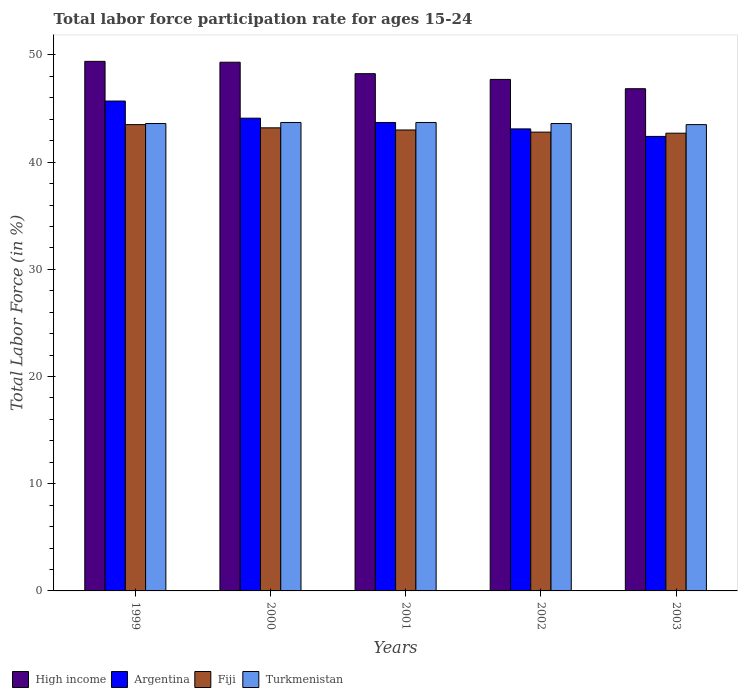Are the number of bars on each tick of the X-axis equal?
Your response must be concise. Yes. How many bars are there on the 4th tick from the left?
Ensure brevity in your answer.  4. What is the labor force participation rate in Argentina in 1999?
Give a very brief answer. 45.7. Across all years, what is the maximum labor force participation rate in Turkmenistan?
Your response must be concise. 43.7. Across all years, what is the minimum labor force participation rate in Fiji?
Provide a succinct answer. 42.7. What is the total labor force participation rate in Turkmenistan in the graph?
Give a very brief answer. 218.1. What is the difference between the labor force participation rate in Argentina in 1999 and that in 2002?
Give a very brief answer. 2.6. What is the difference between the labor force participation rate in Argentina in 2000 and the labor force participation rate in High income in 2002?
Keep it short and to the point. -3.62. What is the average labor force participation rate in Argentina per year?
Provide a short and direct response. 43.8. In the year 2003, what is the difference between the labor force participation rate in Turkmenistan and labor force participation rate in High income?
Make the answer very short. -3.35. What is the ratio of the labor force participation rate in Turkmenistan in 1999 to that in 2003?
Provide a succinct answer. 1. Is the labor force participation rate in Argentina in 2001 less than that in 2003?
Provide a succinct answer. No. What is the difference between the highest and the second highest labor force participation rate in Fiji?
Ensure brevity in your answer.  0.3. What is the difference between the highest and the lowest labor force participation rate in Turkmenistan?
Provide a succinct answer. 0.2. Is the sum of the labor force participation rate in Argentina in 2001 and 2002 greater than the maximum labor force participation rate in Turkmenistan across all years?
Your answer should be compact. Yes. Is it the case that in every year, the sum of the labor force participation rate in High income and labor force participation rate in Argentina is greater than the sum of labor force participation rate in Fiji and labor force participation rate in Turkmenistan?
Your response must be concise. No. What does the 2nd bar from the left in 2002 represents?
Your answer should be very brief. Argentina. What does the 1st bar from the right in 2000 represents?
Ensure brevity in your answer.  Turkmenistan. How many years are there in the graph?
Your answer should be compact. 5. Are the values on the major ticks of Y-axis written in scientific E-notation?
Make the answer very short. No. Does the graph contain grids?
Make the answer very short. No. How are the legend labels stacked?
Provide a succinct answer. Horizontal. What is the title of the graph?
Your answer should be very brief. Total labor force participation rate for ages 15-24. What is the label or title of the Y-axis?
Offer a terse response. Total Labor Force (in %). What is the Total Labor Force (in %) of High income in 1999?
Give a very brief answer. 49.4. What is the Total Labor Force (in %) of Argentina in 1999?
Your answer should be compact. 45.7. What is the Total Labor Force (in %) in Fiji in 1999?
Offer a terse response. 43.5. What is the Total Labor Force (in %) of Turkmenistan in 1999?
Keep it short and to the point. 43.6. What is the Total Labor Force (in %) in High income in 2000?
Provide a succinct answer. 49.32. What is the Total Labor Force (in %) of Argentina in 2000?
Make the answer very short. 44.1. What is the Total Labor Force (in %) in Fiji in 2000?
Provide a succinct answer. 43.2. What is the Total Labor Force (in %) of Turkmenistan in 2000?
Your response must be concise. 43.7. What is the Total Labor Force (in %) in High income in 2001?
Ensure brevity in your answer.  48.25. What is the Total Labor Force (in %) of Argentina in 2001?
Give a very brief answer. 43.7. What is the Total Labor Force (in %) of Turkmenistan in 2001?
Provide a short and direct response. 43.7. What is the Total Labor Force (in %) of High income in 2002?
Provide a short and direct response. 47.72. What is the Total Labor Force (in %) in Argentina in 2002?
Give a very brief answer. 43.1. What is the Total Labor Force (in %) in Fiji in 2002?
Offer a very short reply. 42.8. What is the Total Labor Force (in %) in Turkmenistan in 2002?
Make the answer very short. 43.6. What is the Total Labor Force (in %) in High income in 2003?
Your answer should be compact. 46.85. What is the Total Labor Force (in %) of Argentina in 2003?
Give a very brief answer. 42.4. What is the Total Labor Force (in %) of Fiji in 2003?
Your response must be concise. 42.7. What is the Total Labor Force (in %) in Turkmenistan in 2003?
Your answer should be very brief. 43.5. Across all years, what is the maximum Total Labor Force (in %) of High income?
Provide a succinct answer. 49.4. Across all years, what is the maximum Total Labor Force (in %) in Argentina?
Make the answer very short. 45.7. Across all years, what is the maximum Total Labor Force (in %) in Fiji?
Ensure brevity in your answer.  43.5. Across all years, what is the maximum Total Labor Force (in %) in Turkmenistan?
Provide a succinct answer. 43.7. Across all years, what is the minimum Total Labor Force (in %) in High income?
Give a very brief answer. 46.85. Across all years, what is the minimum Total Labor Force (in %) in Argentina?
Ensure brevity in your answer.  42.4. Across all years, what is the minimum Total Labor Force (in %) of Fiji?
Your answer should be compact. 42.7. Across all years, what is the minimum Total Labor Force (in %) of Turkmenistan?
Ensure brevity in your answer.  43.5. What is the total Total Labor Force (in %) in High income in the graph?
Make the answer very short. 241.54. What is the total Total Labor Force (in %) in Argentina in the graph?
Ensure brevity in your answer.  219. What is the total Total Labor Force (in %) in Fiji in the graph?
Your answer should be very brief. 215.2. What is the total Total Labor Force (in %) of Turkmenistan in the graph?
Ensure brevity in your answer.  218.1. What is the difference between the Total Labor Force (in %) of High income in 1999 and that in 2000?
Provide a short and direct response. 0.08. What is the difference between the Total Labor Force (in %) of High income in 1999 and that in 2001?
Provide a succinct answer. 1.15. What is the difference between the Total Labor Force (in %) in High income in 1999 and that in 2002?
Offer a terse response. 1.68. What is the difference between the Total Labor Force (in %) in Argentina in 1999 and that in 2002?
Offer a very short reply. 2.6. What is the difference between the Total Labor Force (in %) of Fiji in 1999 and that in 2002?
Offer a terse response. 0.7. What is the difference between the Total Labor Force (in %) of Turkmenistan in 1999 and that in 2002?
Make the answer very short. 0. What is the difference between the Total Labor Force (in %) of High income in 1999 and that in 2003?
Provide a short and direct response. 2.55. What is the difference between the Total Labor Force (in %) of Fiji in 1999 and that in 2003?
Make the answer very short. 0.8. What is the difference between the Total Labor Force (in %) in Turkmenistan in 1999 and that in 2003?
Your answer should be very brief. 0.1. What is the difference between the Total Labor Force (in %) of High income in 2000 and that in 2001?
Ensure brevity in your answer.  1.07. What is the difference between the Total Labor Force (in %) of Fiji in 2000 and that in 2001?
Your answer should be compact. 0.2. What is the difference between the Total Labor Force (in %) of High income in 2000 and that in 2002?
Make the answer very short. 1.6. What is the difference between the Total Labor Force (in %) of Argentina in 2000 and that in 2002?
Give a very brief answer. 1. What is the difference between the Total Labor Force (in %) of Fiji in 2000 and that in 2002?
Your answer should be very brief. 0.4. What is the difference between the Total Labor Force (in %) of Turkmenistan in 2000 and that in 2002?
Your answer should be compact. 0.1. What is the difference between the Total Labor Force (in %) in High income in 2000 and that in 2003?
Offer a terse response. 2.47. What is the difference between the Total Labor Force (in %) of Argentina in 2000 and that in 2003?
Provide a short and direct response. 1.7. What is the difference between the Total Labor Force (in %) of Turkmenistan in 2000 and that in 2003?
Ensure brevity in your answer.  0.2. What is the difference between the Total Labor Force (in %) in High income in 2001 and that in 2002?
Offer a very short reply. 0.53. What is the difference between the Total Labor Force (in %) in Argentina in 2001 and that in 2002?
Your answer should be very brief. 0.6. What is the difference between the Total Labor Force (in %) in Fiji in 2001 and that in 2002?
Keep it short and to the point. 0.2. What is the difference between the Total Labor Force (in %) in High income in 2001 and that in 2003?
Keep it short and to the point. 1.4. What is the difference between the Total Labor Force (in %) in Argentina in 2001 and that in 2003?
Make the answer very short. 1.3. What is the difference between the Total Labor Force (in %) of High income in 2002 and that in 2003?
Offer a very short reply. 0.87. What is the difference between the Total Labor Force (in %) of Fiji in 2002 and that in 2003?
Provide a short and direct response. 0.1. What is the difference between the Total Labor Force (in %) in High income in 1999 and the Total Labor Force (in %) in Argentina in 2000?
Keep it short and to the point. 5.3. What is the difference between the Total Labor Force (in %) of High income in 1999 and the Total Labor Force (in %) of Fiji in 2000?
Ensure brevity in your answer.  6.2. What is the difference between the Total Labor Force (in %) in High income in 1999 and the Total Labor Force (in %) in Turkmenistan in 2000?
Provide a short and direct response. 5.7. What is the difference between the Total Labor Force (in %) of Argentina in 1999 and the Total Labor Force (in %) of Turkmenistan in 2000?
Offer a terse response. 2. What is the difference between the Total Labor Force (in %) of High income in 1999 and the Total Labor Force (in %) of Argentina in 2001?
Your answer should be compact. 5.7. What is the difference between the Total Labor Force (in %) of High income in 1999 and the Total Labor Force (in %) of Fiji in 2001?
Ensure brevity in your answer.  6.4. What is the difference between the Total Labor Force (in %) in High income in 1999 and the Total Labor Force (in %) in Turkmenistan in 2001?
Give a very brief answer. 5.7. What is the difference between the Total Labor Force (in %) of Fiji in 1999 and the Total Labor Force (in %) of Turkmenistan in 2001?
Ensure brevity in your answer.  -0.2. What is the difference between the Total Labor Force (in %) of High income in 1999 and the Total Labor Force (in %) of Argentina in 2002?
Provide a short and direct response. 6.3. What is the difference between the Total Labor Force (in %) in High income in 1999 and the Total Labor Force (in %) in Fiji in 2002?
Give a very brief answer. 6.6. What is the difference between the Total Labor Force (in %) of High income in 1999 and the Total Labor Force (in %) of Turkmenistan in 2002?
Your response must be concise. 5.8. What is the difference between the Total Labor Force (in %) of High income in 1999 and the Total Labor Force (in %) of Argentina in 2003?
Your answer should be compact. 7. What is the difference between the Total Labor Force (in %) of High income in 1999 and the Total Labor Force (in %) of Fiji in 2003?
Your answer should be very brief. 6.7. What is the difference between the Total Labor Force (in %) of High income in 1999 and the Total Labor Force (in %) of Turkmenistan in 2003?
Keep it short and to the point. 5.9. What is the difference between the Total Labor Force (in %) in Argentina in 1999 and the Total Labor Force (in %) in Fiji in 2003?
Ensure brevity in your answer.  3. What is the difference between the Total Labor Force (in %) in Fiji in 1999 and the Total Labor Force (in %) in Turkmenistan in 2003?
Your response must be concise. 0. What is the difference between the Total Labor Force (in %) in High income in 2000 and the Total Labor Force (in %) in Argentina in 2001?
Offer a very short reply. 5.62. What is the difference between the Total Labor Force (in %) in High income in 2000 and the Total Labor Force (in %) in Fiji in 2001?
Your answer should be very brief. 6.32. What is the difference between the Total Labor Force (in %) in High income in 2000 and the Total Labor Force (in %) in Turkmenistan in 2001?
Offer a terse response. 5.62. What is the difference between the Total Labor Force (in %) in High income in 2000 and the Total Labor Force (in %) in Argentina in 2002?
Make the answer very short. 6.22. What is the difference between the Total Labor Force (in %) of High income in 2000 and the Total Labor Force (in %) of Fiji in 2002?
Give a very brief answer. 6.52. What is the difference between the Total Labor Force (in %) in High income in 2000 and the Total Labor Force (in %) in Turkmenistan in 2002?
Provide a short and direct response. 5.72. What is the difference between the Total Labor Force (in %) of Argentina in 2000 and the Total Labor Force (in %) of Fiji in 2002?
Offer a very short reply. 1.3. What is the difference between the Total Labor Force (in %) in High income in 2000 and the Total Labor Force (in %) in Argentina in 2003?
Ensure brevity in your answer.  6.92. What is the difference between the Total Labor Force (in %) in High income in 2000 and the Total Labor Force (in %) in Fiji in 2003?
Your response must be concise. 6.62. What is the difference between the Total Labor Force (in %) of High income in 2000 and the Total Labor Force (in %) of Turkmenistan in 2003?
Your response must be concise. 5.82. What is the difference between the Total Labor Force (in %) in Argentina in 2000 and the Total Labor Force (in %) in Turkmenistan in 2003?
Provide a succinct answer. 0.6. What is the difference between the Total Labor Force (in %) in Fiji in 2000 and the Total Labor Force (in %) in Turkmenistan in 2003?
Provide a short and direct response. -0.3. What is the difference between the Total Labor Force (in %) of High income in 2001 and the Total Labor Force (in %) of Argentina in 2002?
Provide a succinct answer. 5.15. What is the difference between the Total Labor Force (in %) in High income in 2001 and the Total Labor Force (in %) in Fiji in 2002?
Your answer should be compact. 5.45. What is the difference between the Total Labor Force (in %) of High income in 2001 and the Total Labor Force (in %) of Turkmenistan in 2002?
Your answer should be compact. 4.65. What is the difference between the Total Labor Force (in %) in Argentina in 2001 and the Total Labor Force (in %) in Turkmenistan in 2002?
Provide a short and direct response. 0.1. What is the difference between the Total Labor Force (in %) in High income in 2001 and the Total Labor Force (in %) in Argentina in 2003?
Your answer should be compact. 5.85. What is the difference between the Total Labor Force (in %) in High income in 2001 and the Total Labor Force (in %) in Fiji in 2003?
Offer a very short reply. 5.55. What is the difference between the Total Labor Force (in %) in High income in 2001 and the Total Labor Force (in %) in Turkmenistan in 2003?
Keep it short and to the point. 4.75. What is the difference between the Total Labor Force (in %) in Argentina in 2001 and the Total Labor Force (in %) in Fiji in 2003?
Your response must be concise. 1. What is the difference between the Total Labor Force (in %) in Fiji in 2001 and the Total Labor Force (in %) in Turkmenistan in 2003?
Offer a very short reply. -0.5. What is the difference between the Total Labor Force (in %) in High income in 2002 and the Total Labor Force (in %) in Argentina in 2003?
Provide a succinct answer. 5.32. What is the difference between the Total Labor Force (in %) of High income in 2002 and the Total Labor Force (in %) of Fiji in 2003?
Provide a succinct answer. 5.02. What is the difference between the Total Labor Force (in %) of High income in 2002 and the Total Labor Force (in %) of Turkmenistan in 2003?
Offer a terse response. 4.22. What is the difference between the Total Labor Force (in %) of Fiji in 2002 and the Total Labor Force (in %) of Turkmenistan in 2003?
Offer a terse response. -0.7. What is the average Total Labor Force (in %) of High income per year?
Your response must be concise. 48.31. What is the average Total Labor Force (in %) in Argentina per year?
Your response must be concise. 43.8. What is the average Total Labor Force (in %) of Fiji per year?
Ensure brevity in your answer.  43.04. What is the average Total Labor Force (in %) in Turkmenistan per year?
Give a very brief answer. 43.62. In the year 1999, what is the difference between the Total Labor Force (in %) in High income and Total Labor Force (in %) in Argentina?
Provide a succinct answer. 3.7. In the year 1999, what is the difference between the Total Labor Force (in %) of High income and Total Labor Force (in %) of Fiji?
Your answer should be very brief. 5.9. In the year 1999, what is the difference between the Total Labor Force (in %) in High income and Total Labor Force (in %) in Turkmenistan?
Make the answer very short. 5.8. In the year 1999, what is the difference between the Total Labor Force (in %) in Argentina and Total Labor Force (in %) in Fiji?
Provide a short and direct response. 2.2. In the year 1999, what is the difference between the Total Labor Force (in %) in Fiji and Total Labor Force (in %) in Turkmenistan?
Your answer should be compact. -0.1. In the year 2000, what is the difference between the Total Labor Force (in %) of High income and Total Labor Force (in %) of Argentina?
Your response must be concise. 5.22. In the year 2000, what is the difference between the Total Labor Force (in %) of High income and Total Labor Force (in %) of Fiji?
Give a very brief answer. 6.12. In the year 2000, what is the difference between the Total Labor Force (in %) of High income and Total Labor Force (in %) of Turkmenistan?
Offer a terse response. 5.62. In the year 2000, what is the difference between the Total Labor Force (in %) of Argentina and Total Labor Force (in %) of Fiji?
Offer a very short reply. 0.9. In the year 2000, what is the difference between the Total Labor Force (in %) in Argentina and Total Labor Force (in %) in Turkmenistan?
Provide a short and direct response. 0.4. In the year 2001, what is the difference between the Total Labor Force (in %) in High income and Total Labor Force (in %) in Argentina?
Make the answer very short. 4.55. In the year 2001, what is the difference between the Total Labor Force (in %) in High income and Total Labor Force (in %) in Fiji?
Offer a terse response. 5.25. In the year 2001, what is the difference between the Total Labor Force (in %) of High income and Total Labor Force (in %) of Turkmenistan?
Offer a very short reply. 4.55. In the year 2001, what is the difference between the Total Labor Force (in %) in Argentina and Total Labor Force (in %) in Turkmenistan?
Keep it short and to the point. 0. In the year 2001, what is the difference between the Total Labor Force (in %) in Fiji and Total Labor Force (in %) in Turkmenistan?
Give a very brief answer. -0.7. In the year 2002, what is the difference between the Total Labor Force (in %) of High income and Total Labor Force (in %) of Argentina?
Provide a short and direct response. 4.62. In the year 2002, what is the difference between the Total Labor Force (in %) of High income and Total Labor Force (in %) of Fiji?
Ensure brevity in your answer.  4.92. In the year 2002, what is the difference between the Total Labor Force (in %) of High income and Total Labor Force (in %) of Turkmenistan?
Your answer should be compact. 4.12. In the year 2003, what is the difference between the Total Labor Force (in %) in High income and Total Labor Force (in %) in Argentina?
Provide a succinct answer. 4.45. In the year 2003, what is the difference between the Total Labor Force (in %) of High income and Total Labor Force (in %) of Fiji?
Your response must be concise. 4.15. In the year 2003, what is the difference between the Total Labor Force (in %) of High income and Total Labor Force (in %) of Turkmenistan?
Provide a succinct answer. 3.35. In the year 2003, what is the difference between the Total Labor Force (in %) in Argentina and Total Labor Force (in %) in Fiji?
Offer a terse response. -0.3. What is the ratio of the Total Labor Force (in %) of Argentina in 1999 to that in 2000?
Make the answer very short. 1.04. What is the ratio of the Total Labor Force (in %) in Turkmenistan in 1999 to that in 2000?
Your answer should be compact. 1. What is the ratio of the Total Labor Force (in %) in High income in 1999 to that in 2001?
Your answer should be very brief. 1.02. What is the ratio of the Total Labor Force (in %) in Argentina in 1999 to that in 2001?
Make the answer very short. 1.05. What is the ratio of the Total Labor Force (in %) in Fiji in 1999 to that in 2001?
Provide a succinct answer. 1.01. What is the ratio of the Total Labor Force (in %) of Turkmenistan in 1999 to that in 2001?
Provide a succinct answer. 1. What is the ratio of the Total Labor Force (in %) of High income in 1999 to that in 2002?
Your answer should be very brief. 1.04. What is the ratio of the Total Labor Force (in %) in Argentina in 1999 to that in 2002?
Your answer should be compact. 1.06. What is the ratio of the Total Labor Force (in %) in Fiji in 1999 to that in 2002?
Make the answer very short. 1.02. What is the ratio of the Total Labor Force (in %) in Turkmenistan in 1999 to that in 2002?
Your response must be concise. 1. What is the ratio of the Total Labor Force (in %) of High income in 1999 to that in 2003?
Keep it short and to the point. 1.05. What is the ratio of the Total Labor Force (in %) of Argentina in 1999 to that in 2003?
Offer a terse response. 1.08. What is the ratio of the Total Labor Force (in %) of Fiji in 1999 to that in 2003?
Offer a very short reply. 1.02. What is the ratio of the Total Labor Force (in %) of Turkmenistan in 1999 to that in 2003?
Provide a succinct answer. 1. What is the ratio of the Total Labor Force (in %) in High income in 2000 to that in 2001?
Offer a terse response. 1.02. What is the ratio of the Total Labor Force (in %) in Argentina in 2000 to that in 2001?
Your answer should be very brief. 1.01. What is the ratio of the Total Labor Force (in %) of Fiji in 2000 to that in 2001?
Your answer should be compact. 1. What is the ratio of the Total Labor Force (in %) in Turkmenistan in 2000 to that in 2001?
Your answer should be very brief. 1. What is the ratio of the Total Labor Force (in %) of High income in 2000 to that in 2002?
Your answer should be compact. 1.03. What is the ratio of the Total Labor Force (in %) in Argentina in 2000 to that in 2002?
Offer a terse response. 1.02. What is the ratio of the Total Labor Force (in %) in Fiji in 2000 to that in 2002?
Offer a terse response. 1.01. What is the ratio of the Total Labor Force (in %) of High income in 2000 to that in 2003?
Your answer should be very brief. 1.05. What is the ratio of the Total Labor Force (in %) of Argentina in 2000 to that in 2003?
Provide a succinct answer. 1.04. What is the ratio of the Total Labor Force (in %) in Fiji in 2000 to that in 2003?
Your answer should be very brief. 1.01. What is the ratio of the Total Labor Force (in %) in High income in 2001 to that in 2002?
Make the answer very short. 1.01. What is the ratio of the Total Labor Force (in %) in Argentina in 2001 to that in 2002?
Offer a very short reply. 1.01. What is the ratio of the Total Labor Force (in %) in Fiji in 2001 to that in 2002?
Provide a short and direct response. 1. What is the ratio of the Total Labor Force (in %) in Turkmenistan in 2001 to that in 2002?
Offer a very short reply. 1. What is the ratio of the Total Labor Force (in %) of High income in 2001 to that in 2003?
Give a very brief answer. 1.03. What is the ratio of the Total Labor Force (in %) of Argentina in 2001 to that in 2003?
Keep it short and to the point. 1.03. What is the ratio of the Total Labor Force (in %) in Fiji in 2001 to that in 2003?
Your response must be concise. 1.01. What is the ratio of the Total Labor Force (in %) in High income in 2002 to that in 2003?
Make the answer very short. 1.02. What is the ratio of the Total Labor Force (in %) in Argentina in 2002 to that in 2003?
Offer a very short reply. 1.02. What is the ratio of the Total Labor Force (in %) in Fiji in 2002 to that in 2003?
Your answer should be compact. 1. What is the difference between the highest and the second highest Total Labor Force (in %) of High income?
Provide a short and direct response. 0.08. What is the difference between the highest and the second highest Total Labor Force (in %) in Argentina?
Your response must be concise. 1.6. What is the difference between the highest and the second highest Total Labor Force (in %) in Turkmenistan?
Make the answer very short. 0. What is the difference between the highest and the lowest Total Labor Force (in %) of High income?
Give a very brief answer. 2.55. What is the difference between the highest and the lowest Total Labor Force (in %) in Argentina?
Provide a short and direct response. 3.3. What is the difference between the highest and the lowest Total Labor Force (in %) of Fiji?
Provide a succinct answer. 0.8. 